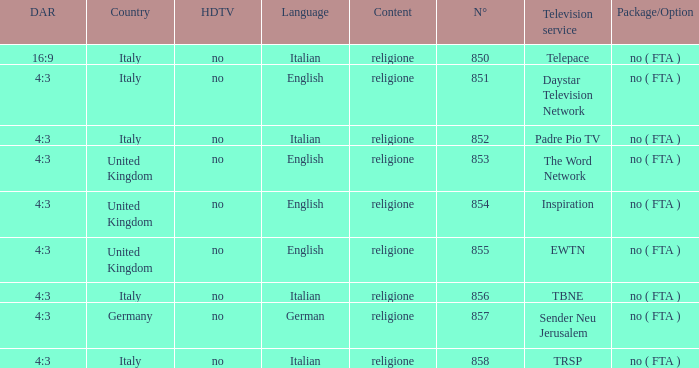How many dar are in germany? 4:3. 